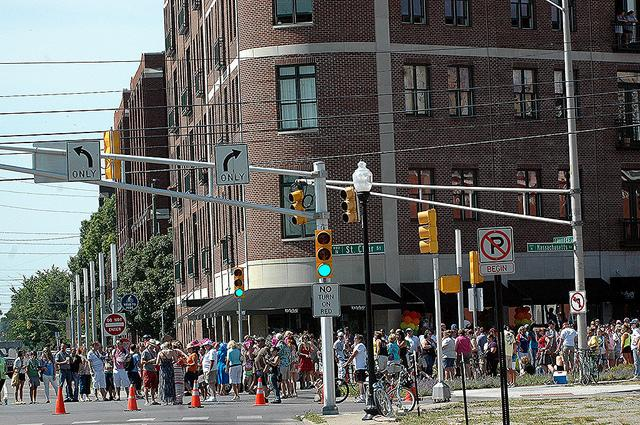Why are the traffic cones positioned in the location that they are? traffic control 